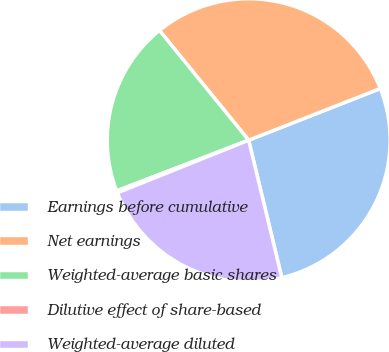<chart> <loc_0><loc_0><loc_500><loc_500><pie_chart><fcel>Earnings before cumulative<fcel>Net earnings<fcel>Weighted-average basic shares<fcel>Dilutive effect of share-based<fcel>Weighted-average diluted<nl><fcel>27.19%<fcel>29.91%<fcel>19.97%<fcel>0.24%<fcel>22.69%<nl></chart> 